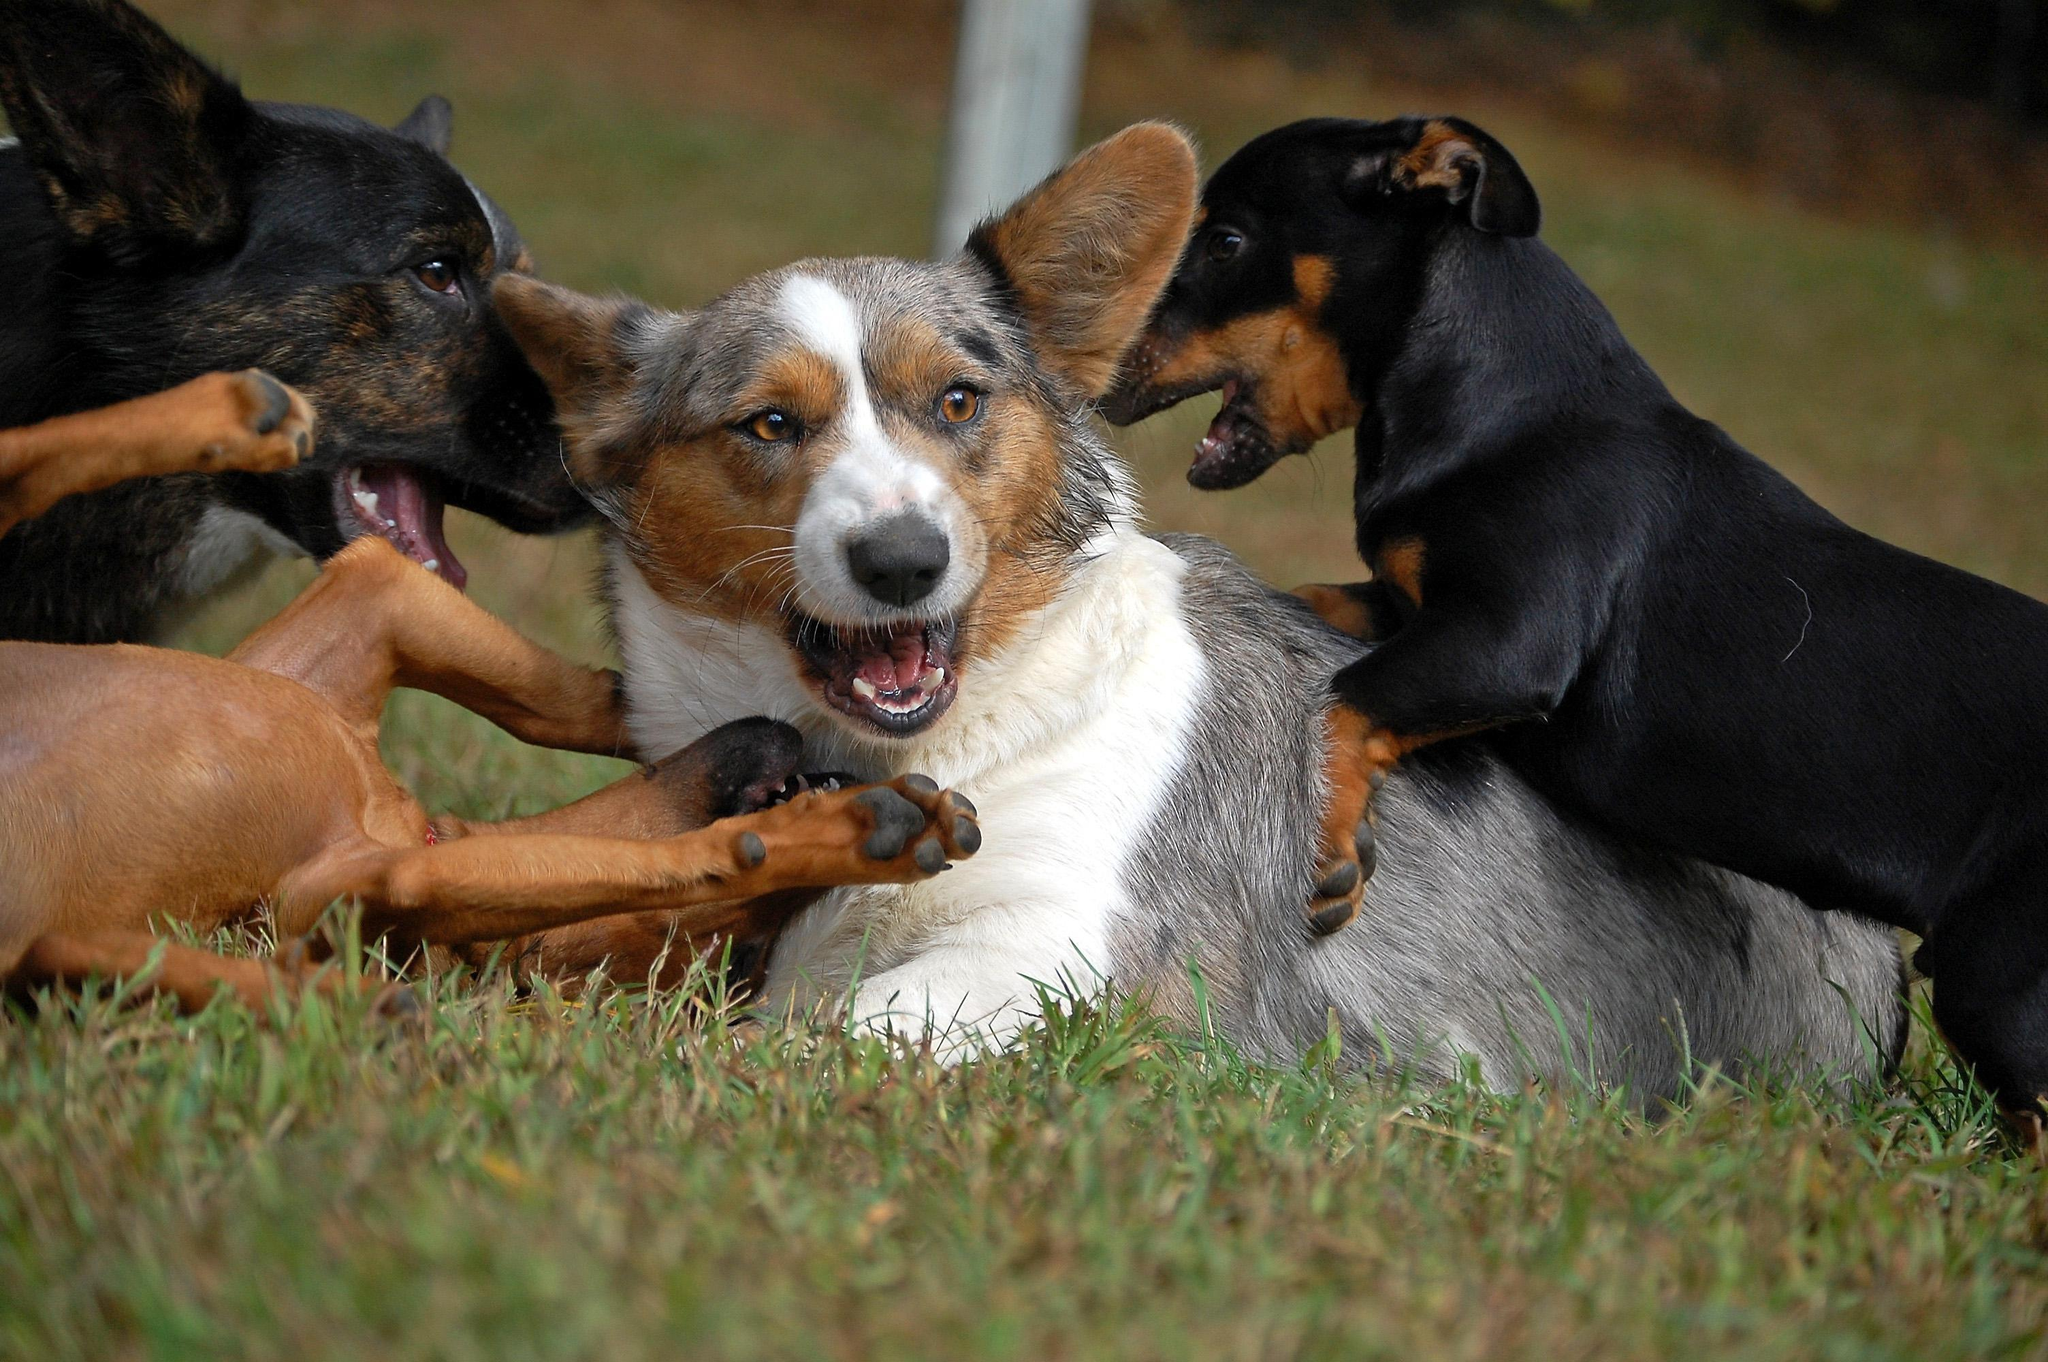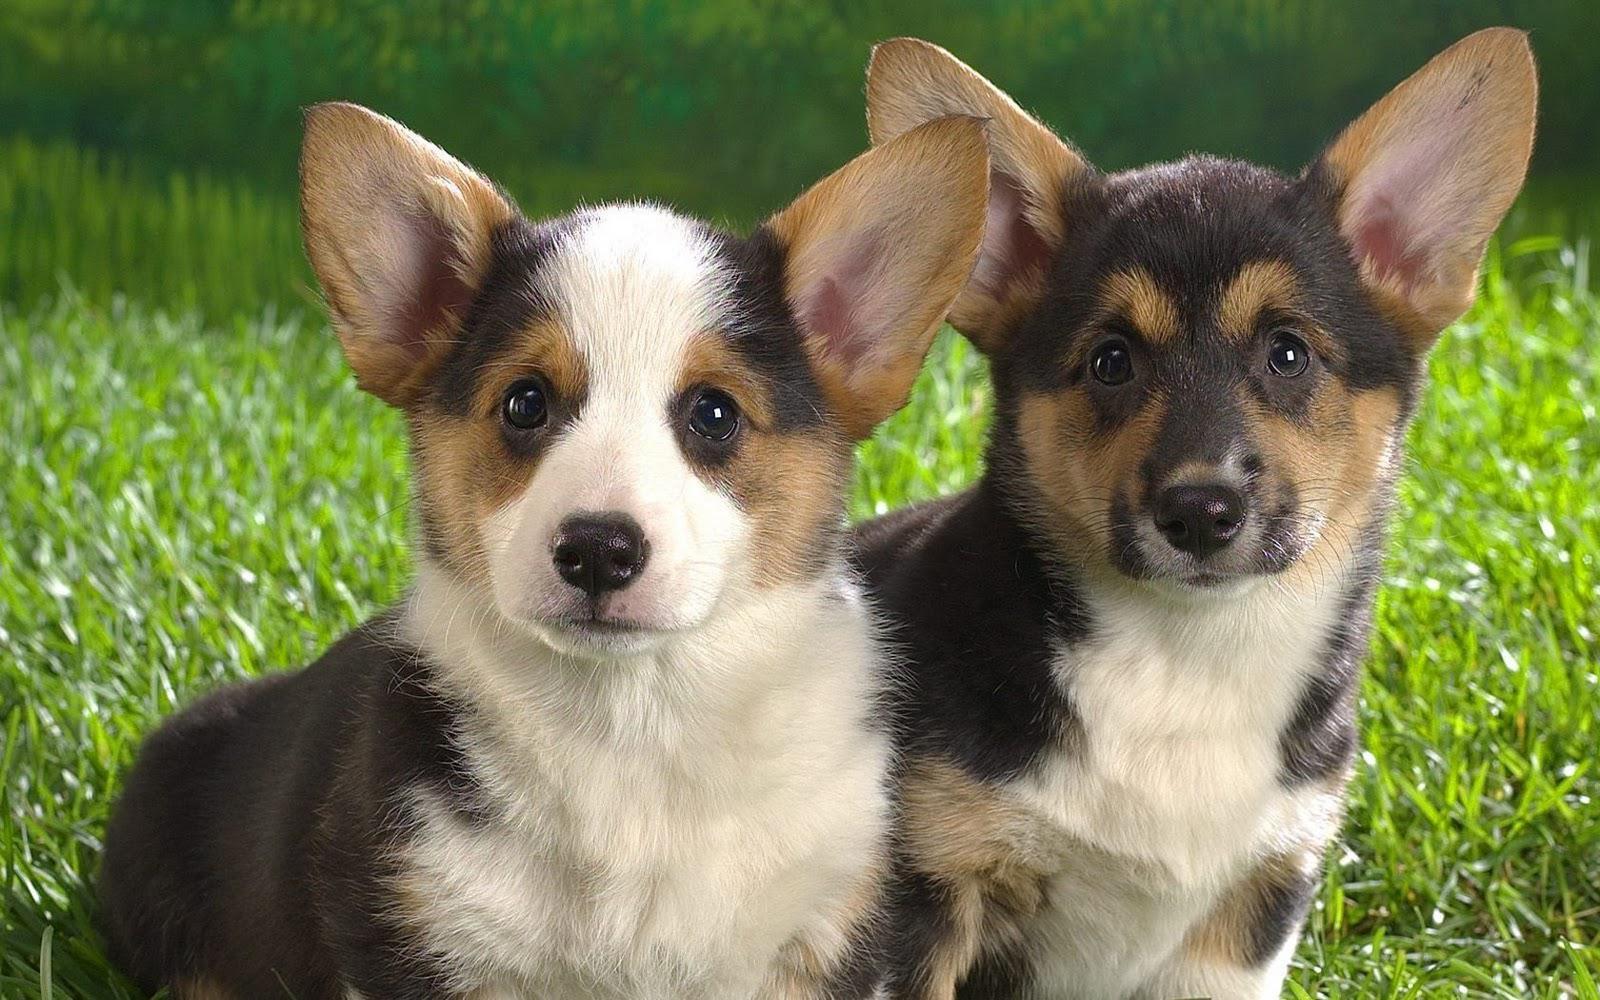The first image is the image on the left, the second image is the image on the right. Analyze the images presented: Is the assertion "There is no more than one dog standing on grass in the left image." valid? Answer yes or no. No. The first image is the image on the left, the second image is the image on the right. Assess this claim about the two images: "In at least one of the images, the corgi is NOT on the grass.". Correct or not? Answer yes or no. No. 